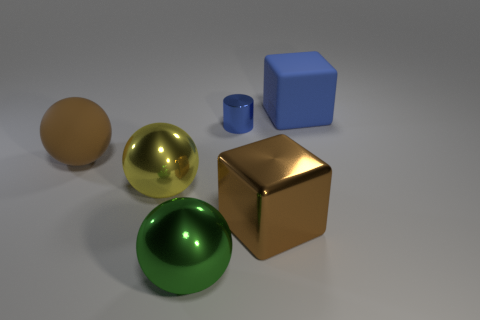What is the brown thing that is right of the large matte object that is in front of the large blue block made of?
Your answer should be compact. Metal. There is a object that is both to the right of the small cylinder and on the left side of the big blue matte thing; what is its shape?
Your answer should be compact. Cube. How many other things are there of the same color as the metallic cylinder?
Provide a short and direct response. 1. How many objects are large matte things that are to the right of the blue metallic object or large brown matte spheres?
Keep it short and to the point. 2. Does the tiny thing have the same color as the metal thing to the left of the green metal ball?
Your answer should be compact. No. Is there anything else that has the same size as the matte ball?
Offer a very short reply. Yes. What is the size of the thing on the right side of the block in front of the large blue block?
Your answer should be compact. Large. What number of things are green objects or large matte objects to the right of the large brown metal thing?
Offer a terse response. 2. There is a large brown object that is on the left side of the big green metallic ball; is its shape the same as the green object?
Your answer should be very brief. Yes. How many metal things are in front of the big rubber ball that is behind the green metallic sphere in front of the brown matte thing?
Offer a terse response. 3. 